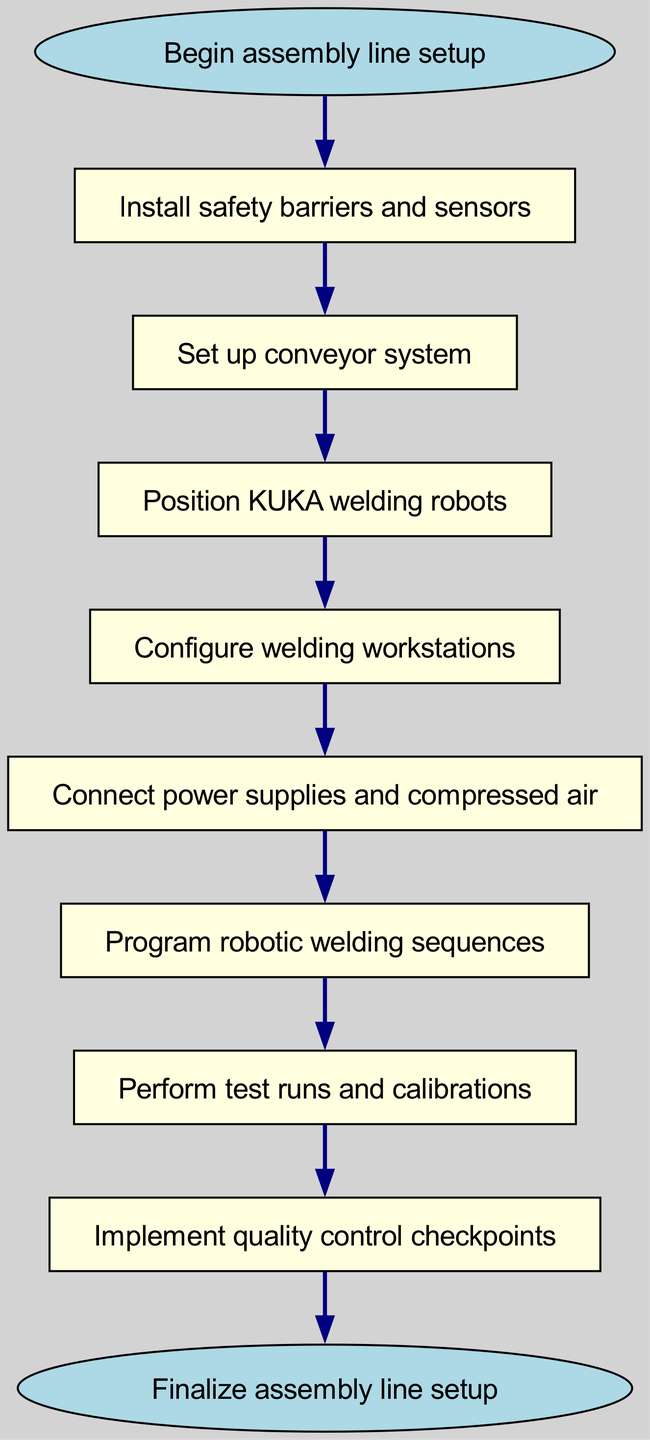What is the first step in the assembly line setup? The first step listed in the diagram is labeled as "Begin assembly line setup," which signifies the starting point of the entire process.
Answer: Begin assembly line setup How many steps are there in total in the flow chart? The flow chart includes a total of 9 steps, as counted from the "Begin assembly line setup" to the "Finalize assembly line setup."
Answer: 9 What is the node that follows the installation of safety barriers and sensors? According to the flow chart, after the installation of safety barriers and sensors, the next step is to "Set up conveyor system."
Answer: Set up conveyor system Which node is connected directly to the "Program robotic welding sequences"? The node directly connected to "Program robotic welding sequences" in the flow chart is "Perform test runs and calibrations," indicating the sequence to carry out after programming.
Answer: Perform test runs and calibrations What is the last step in the process description? The final step in the process, as outlined in the diagram, is "Finalize assembly line setup," marking the completion of the setup.
Answer: Finalize assembly line setup What is the relationship between "Position KUKA welding robots" and "Configure welding workstations"? According to the diagram, "Position KUKA welding robots" leads directly into "Configure welding workstations," indicating that configuring the workstations cannot occur until the robots are positioned.
Answer: Position KUKA welding robots leads to Configure welding workstations What is the purpose of "Implement quality control checkpoints"? The purpose of "Implement quality control checkpoints" in the flow chart is to ensure that all assembly steps have met the specified quality standards before finalizing the setup.
Answer: Ensure quality standards Which two nodes are connected by an edge representing a prerequisite relationship? An example of a prerequisite relationship is between "Connect power supplies and compressed air" and "Program robotic welding sequences," as the latter cannot occur without first connecting power and air.
Answer: Connect power supplies and compressed air to Program robotic welding sequences What physical preparations must be done before configuring welding workstations? Before configuring welding workstations, the preceding step is "Position KUKA welding robots," indicating that the robots must be correctly placed first.
Answer: Position KUKA welding robots 